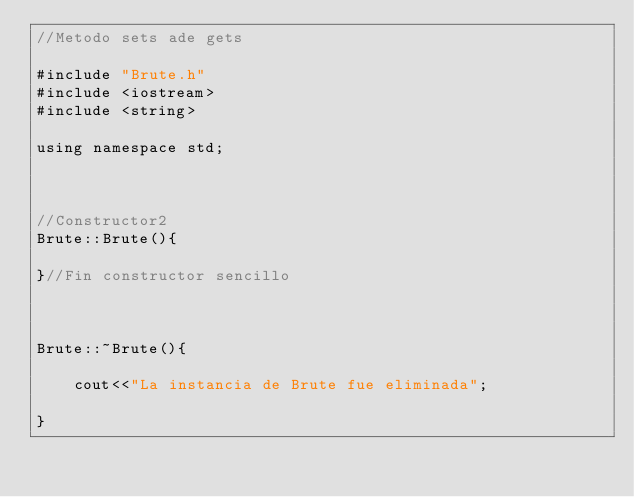<code> <loc_0><loc_0><loc_500><loc_500><_C++_>//Metodo sets ade gets

#include "Brute.h"
#include <iostream>
#include <string>

using namespace std;



//Constructor2
Brute::Brute(){

}//Fin constructor sencillo



Brute::~Brute(){

    cout<<"La instancia de Brute fue eliminada";

}</code> 